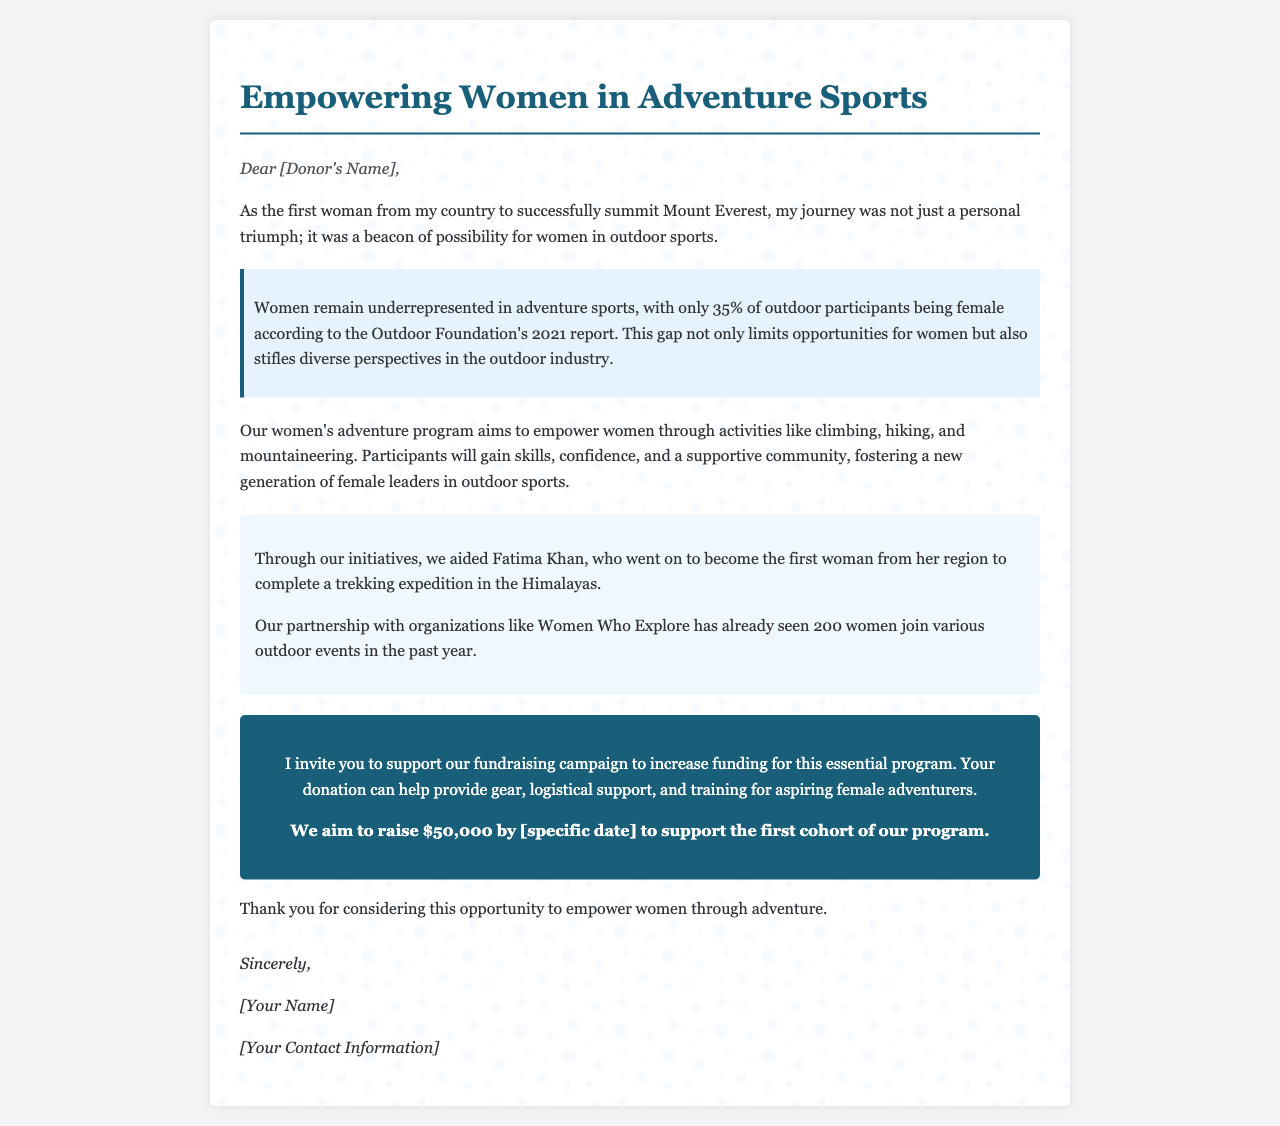what percentage of outdoor participants are female? The document states that only 35% of outdoor participants are female according to the Outdoor Foundation's 2021 report.
Answer: 35% who is mentioned as a success story in the program? The letter references Fatima Khan as a success story who became the first woman from her region to complete a trekking expedition in the Himalayas.
Answer: Fatima Khan how much money does the fundraising campaign aim to raise? The campaign aims to raise $50,000 to support the first cohort of the program.
Answer: $50,000 what activities are emphasized in the women's adventure program? The program focuses on activities like climbing, hiking, and mountaineering.
Answer: climbing, hiking, mountaineering who partnered with the program to engage women in outdoor events? The program has a partnership with Women Who Explore, which has successfully seen participation from women.
Answer: Women Who Explore what is the purpose of the fundraising campaign? The campaign is aimed at increasing funding for the women's adventure program to provide necessary support.
Answer: provide necessary support what date is referenced for the fundraising goal? The specific date is mentioned as [specific date] which denotes a placeholder for when the funds are needed by.
Answer: [specific date] who wrote the letter? The letter is signed by [Your Name], which signifies the individual behind the fundraising efforts.
Answer: [Your Name] 